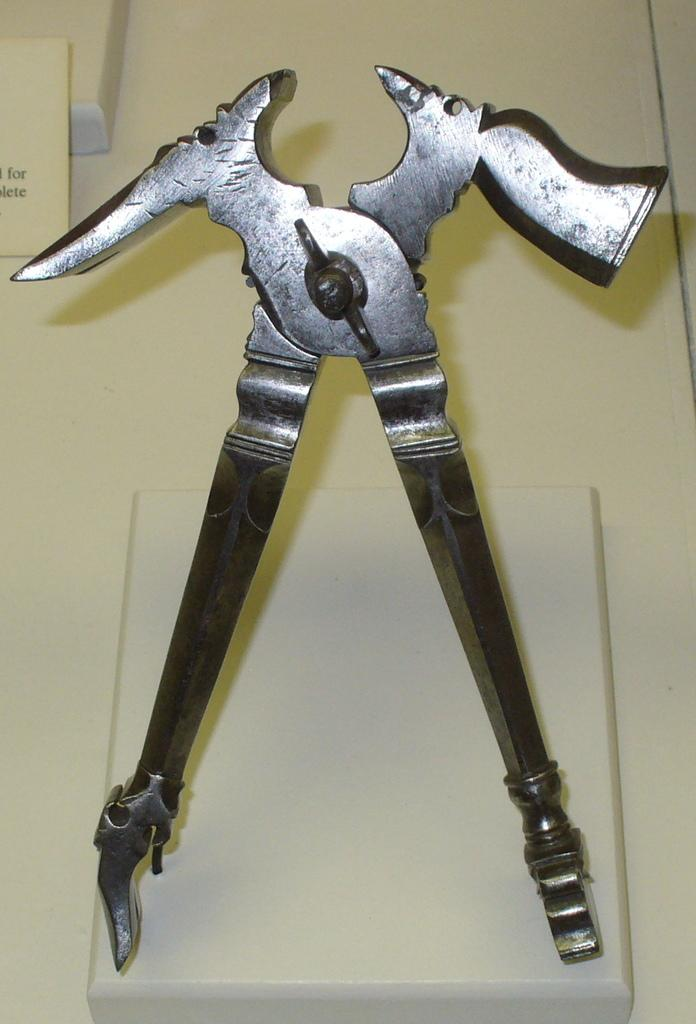What object can be seen on the surface in the image? There is a tool on the surface in the image. What is located towards the left of the image? There is a truncated board towards the left of the image. What is written or depicted on the board? There is text on the board. What can be seen in the background of the image? There is a wall in the background of the image. How many stamps are visible on the wall in the image? There are no stamps visible on the wall in the image. Is there a light bulb hanging from the ceiling in the image? There is no mention of a light bulb or any other lighting fixture in the image. 